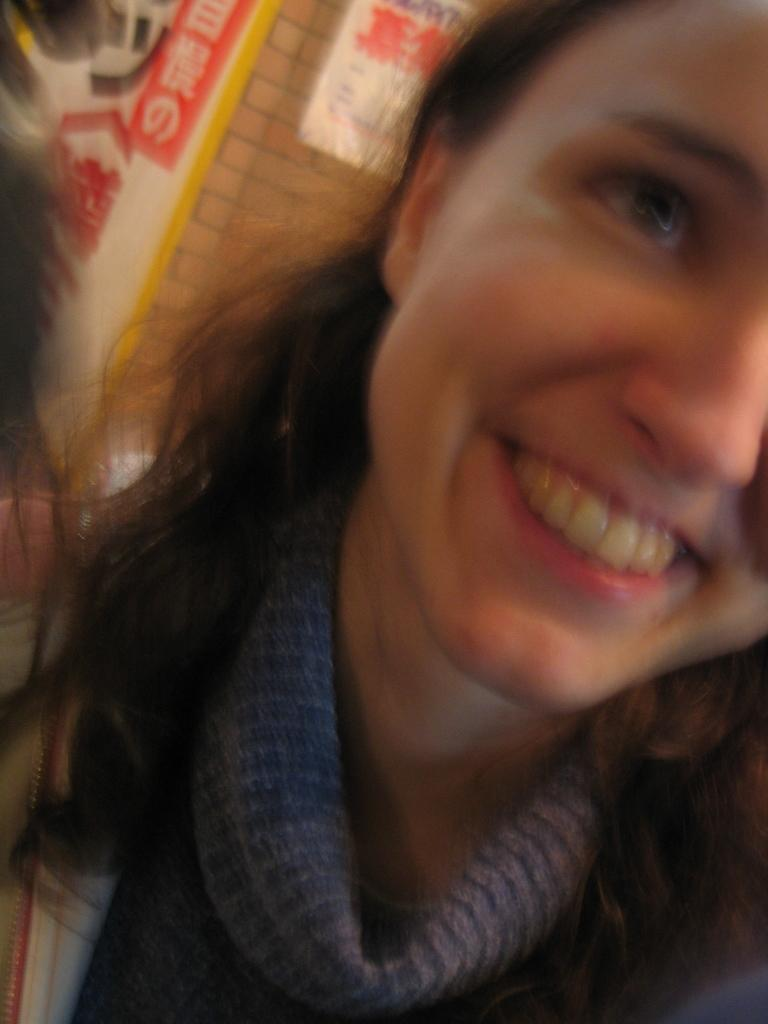What is the main subject of the image? The main subject of the image is a woman. Can you describe the woman's expression in the image? The woman is smiling in the image. What is visible in the background of the image? There is a wall in the background of the image. What type of cheese can be seen hanging from the wall in the image? There is no cheese present in the image, and therefore no such object can be observed. 